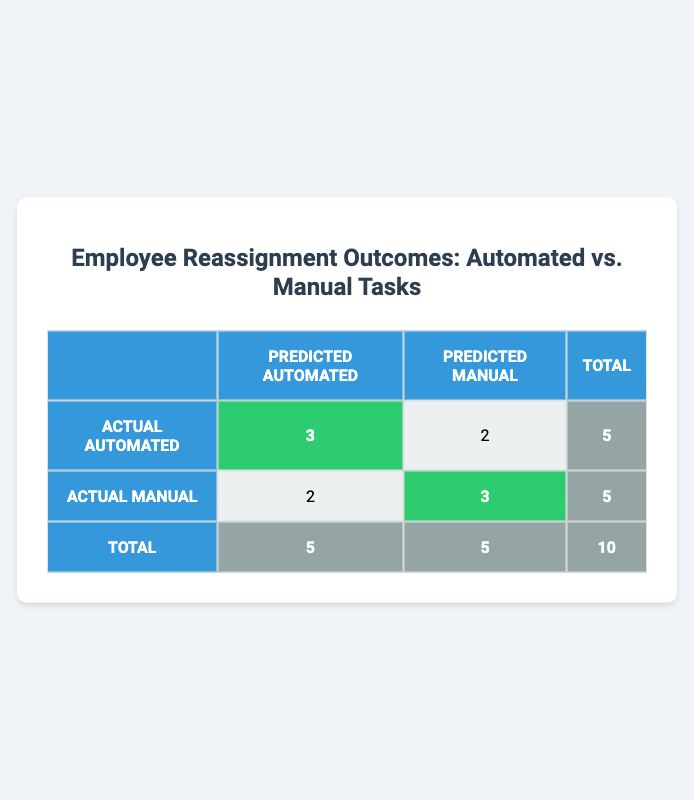What is the total number of employees who had their tasks reassigned? The total number of employees can be found in the last row of the table, labeled “Total,” which indicates there are 10 employees in total.
Answer: 10 How many employees had successful reassignments for automated tasks? In the table, under “Actual Automated,” the cell corresponding to “Predicted Automated” shows 3, indicating there are 3 successful reassignments for automated tasks.
Answer: 3 What is the total number of employees that had unsuccessful reassignments? To find this, we sum the number of unsuccessful reassignments from both task types. There are 2 unsuccessful automated and 2 unsuccessful manual, totaling 4.
Answer: 4 Is it true that more employees had successful reassignments with manual tasks than with automated tasks? By looking at the table, manual tasks show 3 successful reassignments (highlighted cell) compared to 3 for automated tasks. Therefore, it is not true that more employees had successful reassignments with manual tasks.
Answer: No What is the difference in the number of successful reassignments between automated and manual tasks? The number of successful reassignments for automated tasks is 3, and for manual tasks, it is also 3. The difference is calculated as 3 - 3 = 0.
Answer: 0 How many employees had their tasks reassigned to predicted manual versus predicted automated tasks? The totals for predicted categories indicate that 5 were predicted to be automated and 5 were predicted to be manual, as shown in the last row of the table under respective columns.
Answer: 5 for each type What percentage of automated task reassigned employees were successful? To find this percentage, we take the number of successful automated reassignments (3), divide it by the total automated reassignments (5), and then multiply by 100: (3/5) * 100 = 60%.
Answer: 60% What is the overall success rate of reassignments for all employees? The total number of successful reassignments is 6 (3 automated + 3 manual), and dividing this by the total number of employees (10) gives a success rate of (6/10) * 100 = 60%.
Answer: 60% 